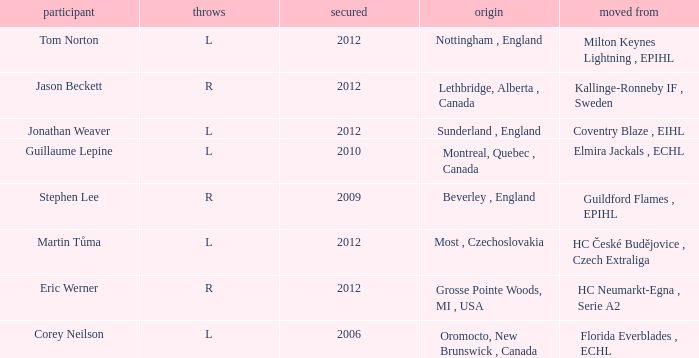Who acquired tom norton? 2012.0. 